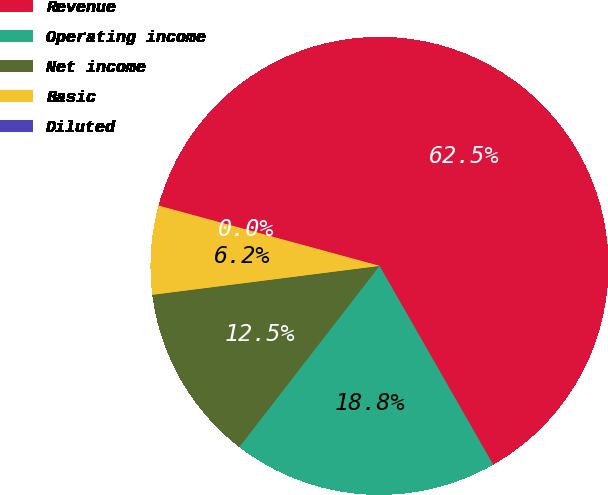Convert chart. <chart><loc_0><loc_0><loc_500><loc_500><pie_chart><fcel>Revenue<fcel>Operating income<fcel>Net income<fcel>Basic<fcel>Diluted<nl><fcel>62.5%<fcel>18.75%<fcel>12.5%<fcel>6.25%<fcel>0.0%<nl></chart> 